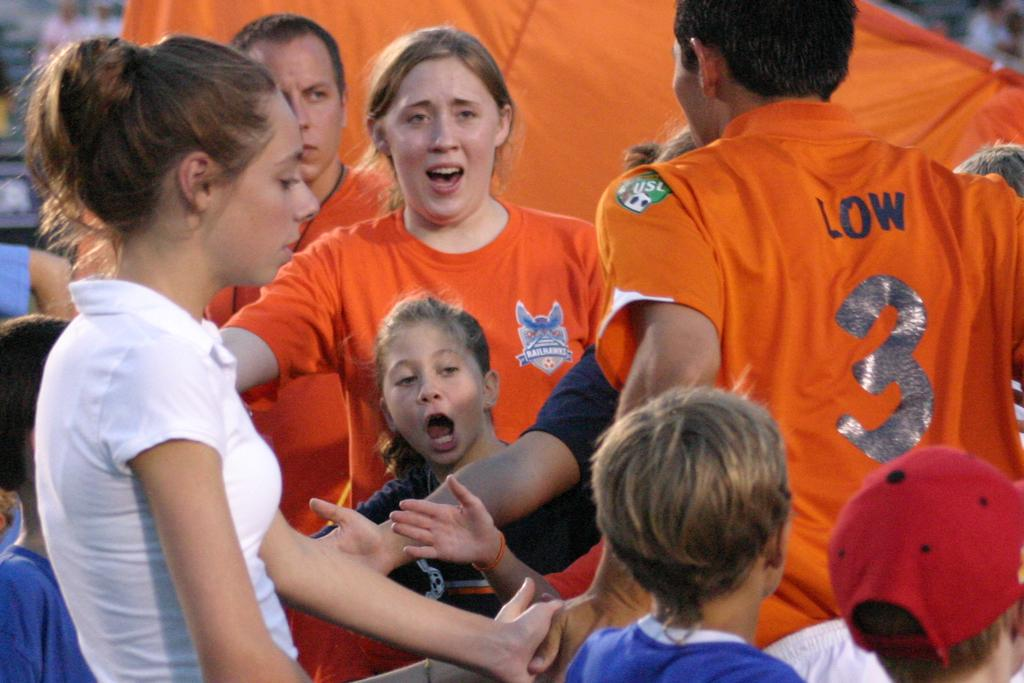Provide a one-sentence caption for the provided image. A group of people gathered around a person with the number three on it. 